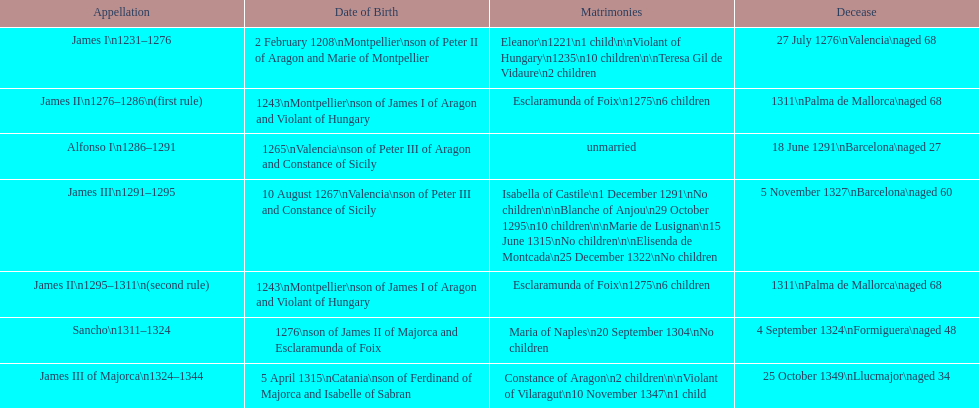Which monarch is listed first? James I 1231-1276. 